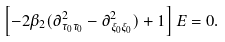Convert formula to latex. <formula><loc_0><loc_0><loc_500><loc_500>\left [ - 2 \beta _ { 2 } ( \partial ^ { 2 } _ { \tau _ { 0 } \tau _ { 0 } } - \partial ^ { 2 } _ { \xi _ { 0 } \xi _ { 0 } } ) + 1 \right ] E = 0 .</formula> 